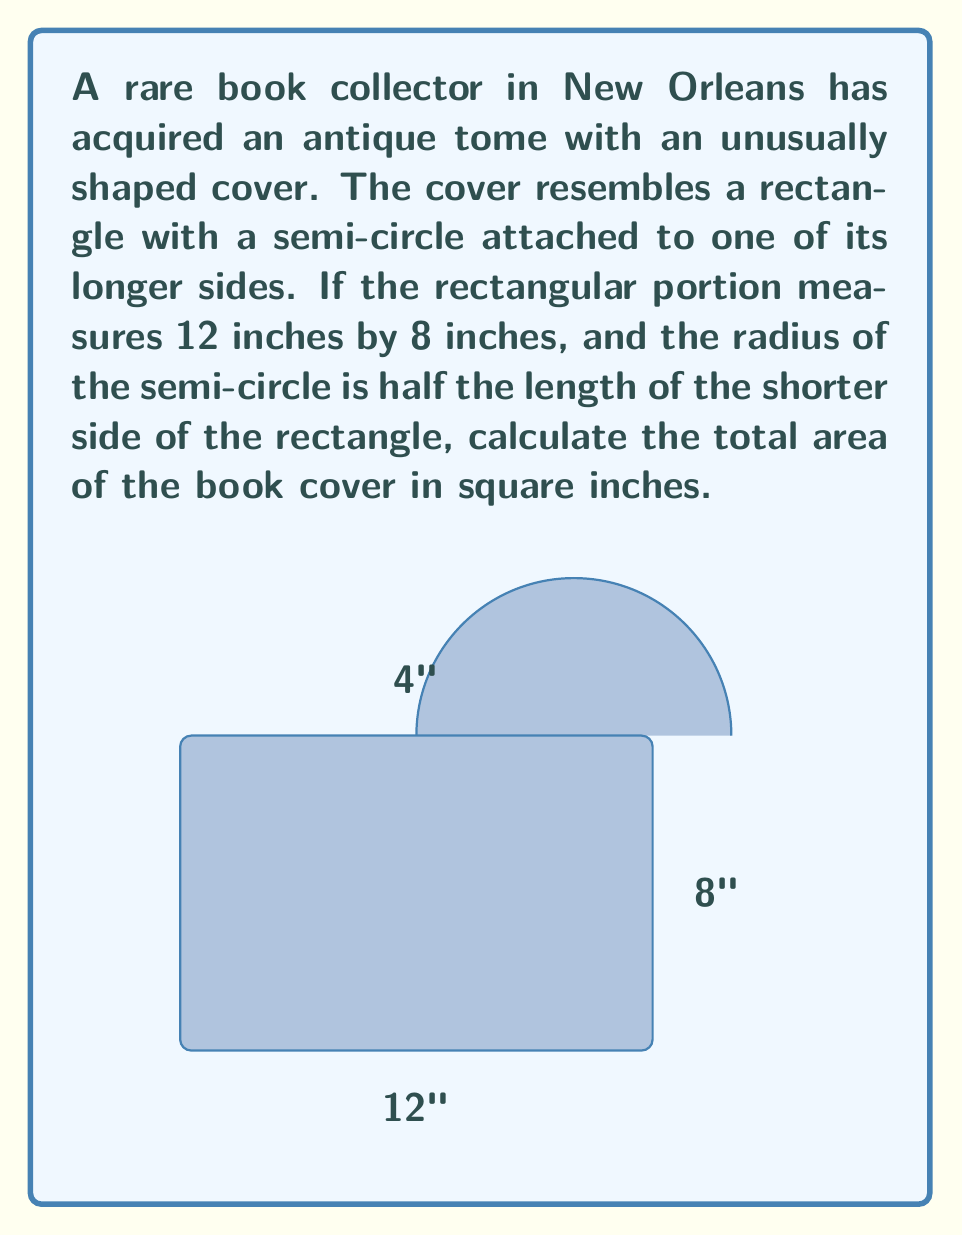Can you answer this question? Let's approach this problem step-by-step:

1) First, we need to calculate the area of the rectangular portion:
   $A_{rectangle} = length \times width = 12 \times 8 = 96$ square inches

2) Now, we need to find the area of the semi-circle:
   - The radius of the semi-circle is half the shorter side of the rectangle
   - Radius = $8 \div 2 = 4$ inches

3) The area of a full circle is given by the formula $A = \pi r^2$
   For a semi-circle, we take half of this:
   $$A_{semi-circle} = \frac{1}{2} \pi r^2$$

4) Substituting the radius:
   $$A_{semi-circle} = \frac{1}{2} \pi (4^2) = 8\pi$$ square inches

5) The total area is the sum of the rectangle and semi-circle areas:
   $$A_{total} = A_{rectangle} + A_{semi-circle} = 96 + 8\pi$$ square inches

6) If we want to give a decimal approximation:
   $$A_{total} \approx 96 + 8(3.14159) \approx 121.13$$ square inches
Answer: $96 + 8\pi$ sq in, or approximately 121.13 sq in 